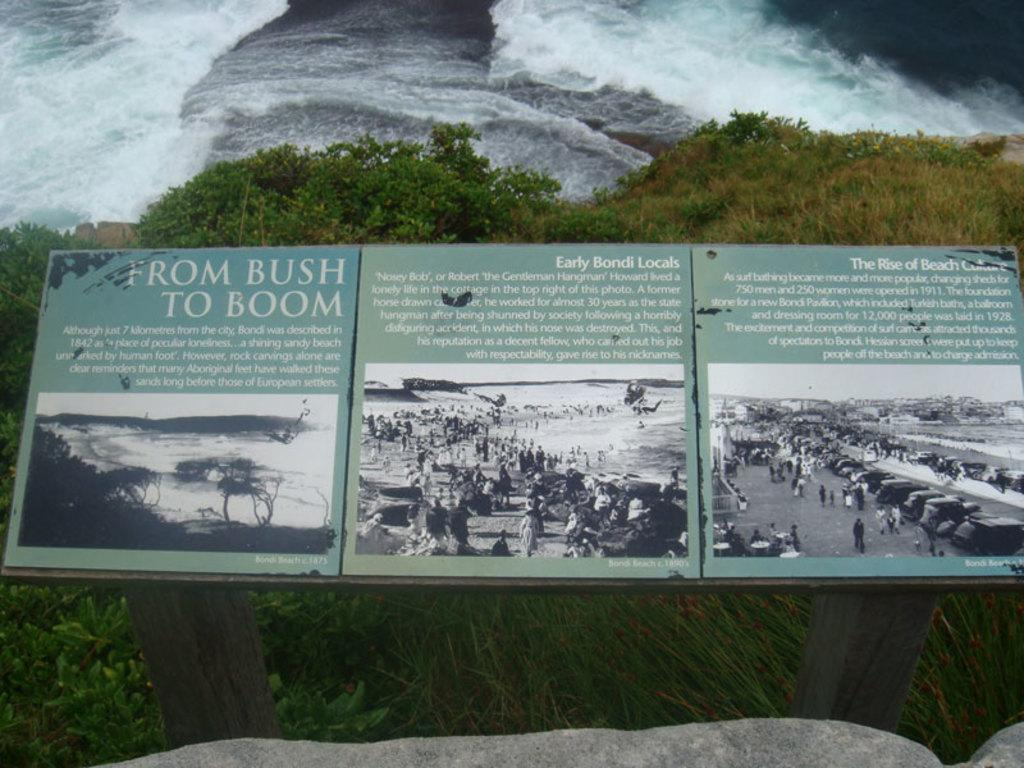What is the main structure in the image? There are boards on wooden poles in the image. What type of natural environment is visible in the image? There is grass and plants visible in the image. What else can be seen in the image besides the boards on wooden poles? There is water visible in the image. What type of bubble is floating near the plants in the image? There is no bubble present in the image. How do the plants in the image relate to each other? The plants in the image are not shown to have any specific relationship with each other. 